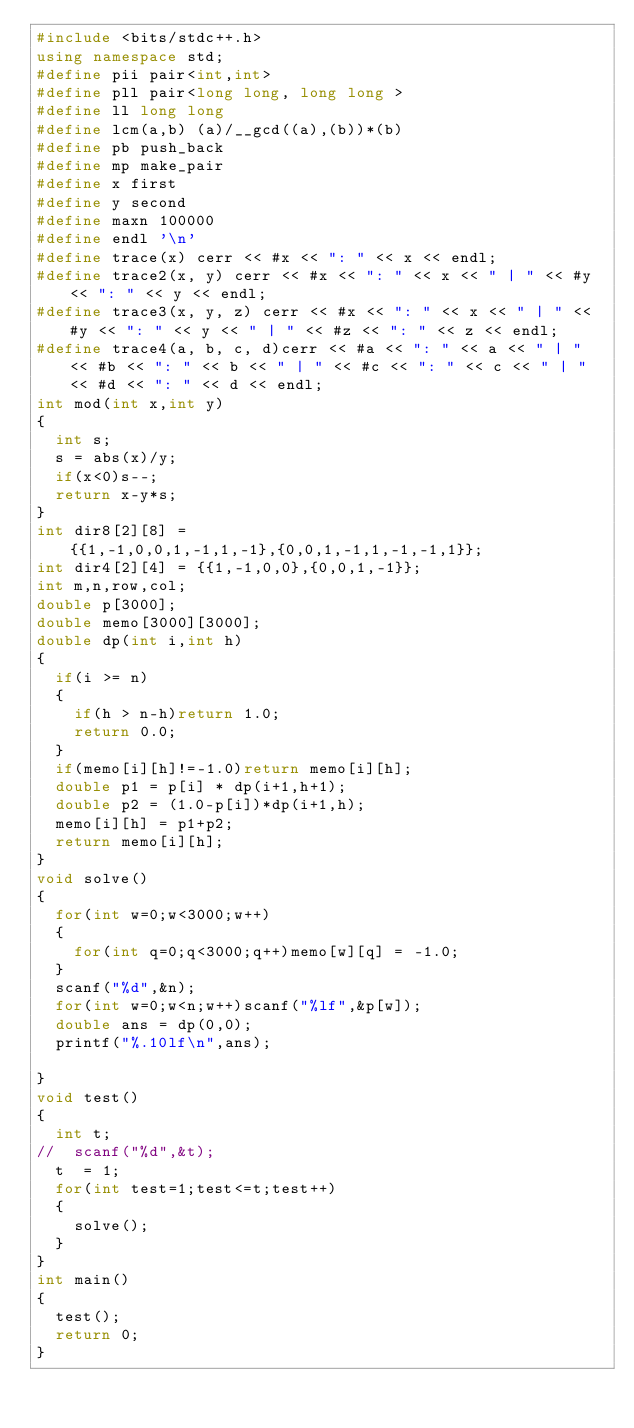Convert code to text. <code><loc_0><loc_0><loc_500><loc_500><_C++_>#include <bits/stdc++.h>
using namespace std;
#define pii pair<int,int>
#define pll pair<long long, long long >
#define ll long long
#define lcm(a,b) (a)/__gcd((a),(b))*(b)
#define pb push_back
#define mp make_pair
#define x first
#define y second
#define maxn 100000
#define endl '\n'
#define trace(x) cerr << #x << ": " << x << endl;
#define trace2(x, y) cerr << #x << ": " << x << " | " << #y << ": " << y << endl;
#define trace3(x, y, z) cerr << #x << ": " << x << " | " << #y << ": " << y << " | " << #z << ": " << z << endl;
#define trace4(a, b, c, d)cerr << #a << ": " << a << " | " << #b << ": " << b << " | " << #c << ": " << c << " | " << #d << ": " << d << endl;
int mod(int x,int y)
{
  int s;
  s = abs(x)/y;
  if(x<0)s--;
  return x-y*s;
}
int dir8[2][8] = {{1,-1,0,0,1,-1,1,-1},{0,0,1,-1,1,-1,-1,1}};
int dir4[2][4] = {{1,-1,0,0},{0,0,1,-1}};
int m,n,row,col;
double p[3000];
double memo[3000][3000];
double dp(int i,int h)
{
  if(i >= n)
  {
    if(h > n-h)return 1.0;
    return 0.0;
  }
  if(memo[i][h]!=-1.0)return memo[i][h];
  double p1 = p[i] * dp(i+1,h+1);
  double p2 = (1.0-p[i])*dp(i+1,h);
  memo[i][h] = p1+p2;
  return memo[i][h];
}
void solve()
{
  for(int w=0;w<3000;w++)
  {
    for(int q=0;q<3000;q++)memo[w][q] = -1.0;
  }
  scanf("%d",&n);
  for(int w=0;w<n;w++)scanf("%lf",&p[w]);
  double ans = dp(0,0);
  printf("%.10lf\n",ans);

}
void test()
{
  int t;
//  scanf("%d",&t);
  t  = 1;
  for(int test=1;test<=t;test++)
  {
    solve();
  }
}
int main()
{
  test();
  return 0;
}
</code> 